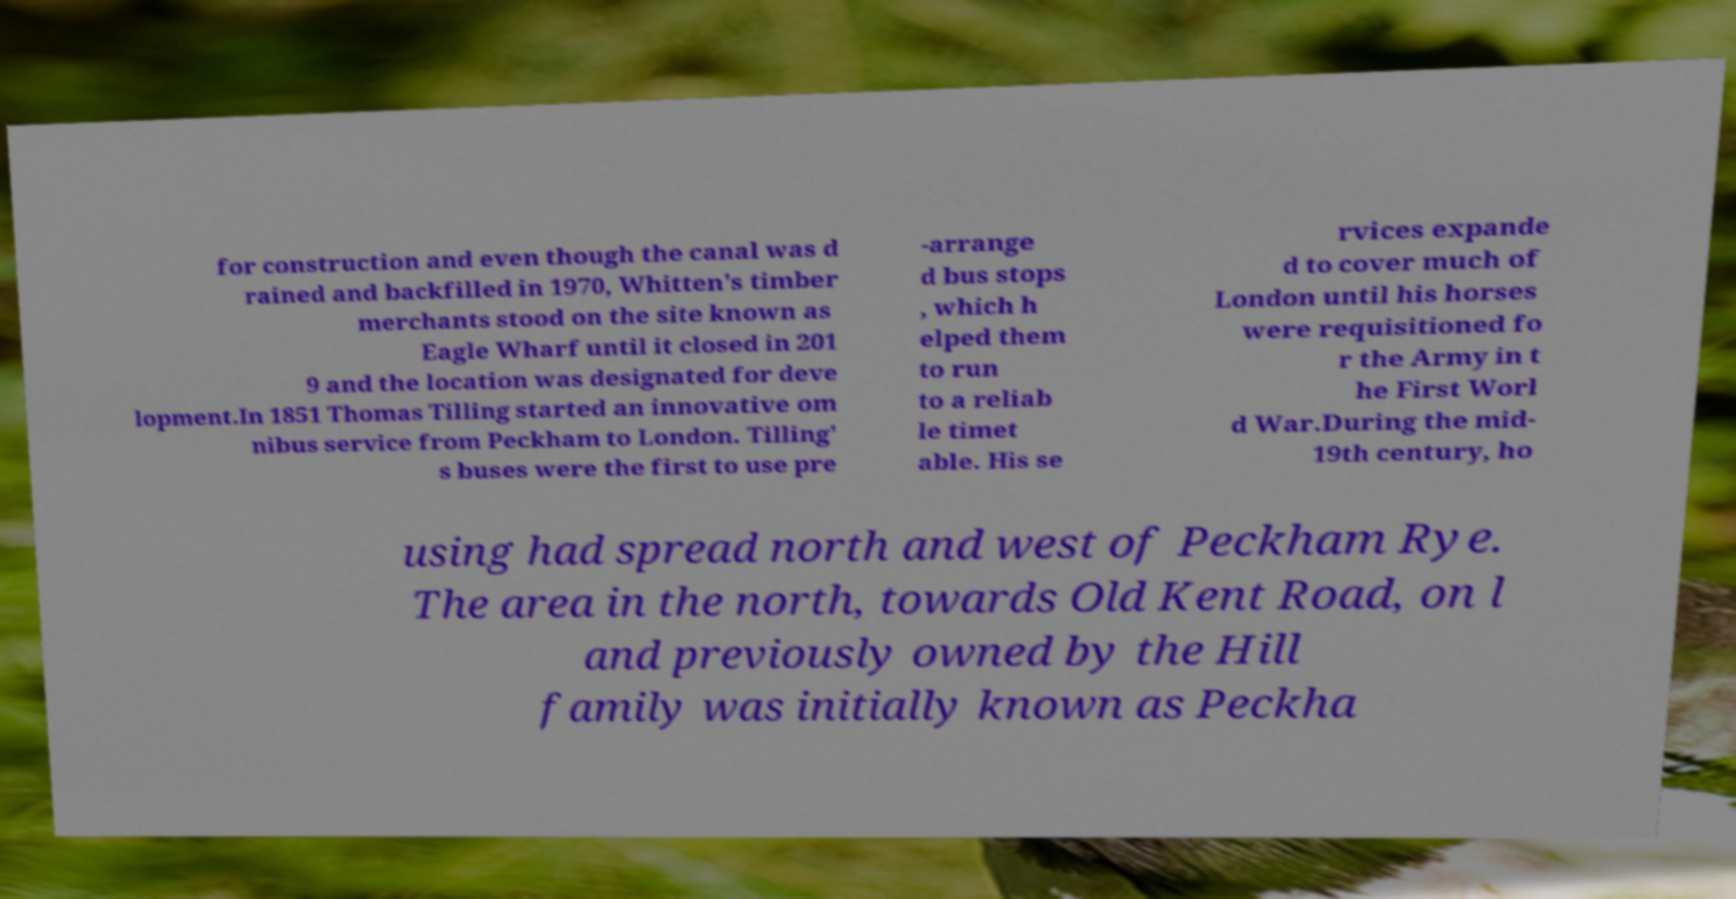What messages or text are displayed in this image? I need them in a readable, typed format. for construction and even though the canal was d rained and backfilled in 1970, Whitten's timber merchants stood on the site known as Eagle Wharf until it closed in 201 9 and the location was designated for deve lopment.In 1851 Thomas Tilling started an innovative om nibus service from Peckham to London. Tilling' s buses were the first to use pre -arrange d bus stops , which h elped them to run to a reliab le timet able. His se rvices expande d to cover much of London until his horses were requisitioned fo r the Army in t he First Worl d War.During the mid- 19th century, ho using had spread north and west of Peckham Rye. The area in the north, towards Old Kent Road, on l and previously owned by the Hill family was initially known as Peckha 